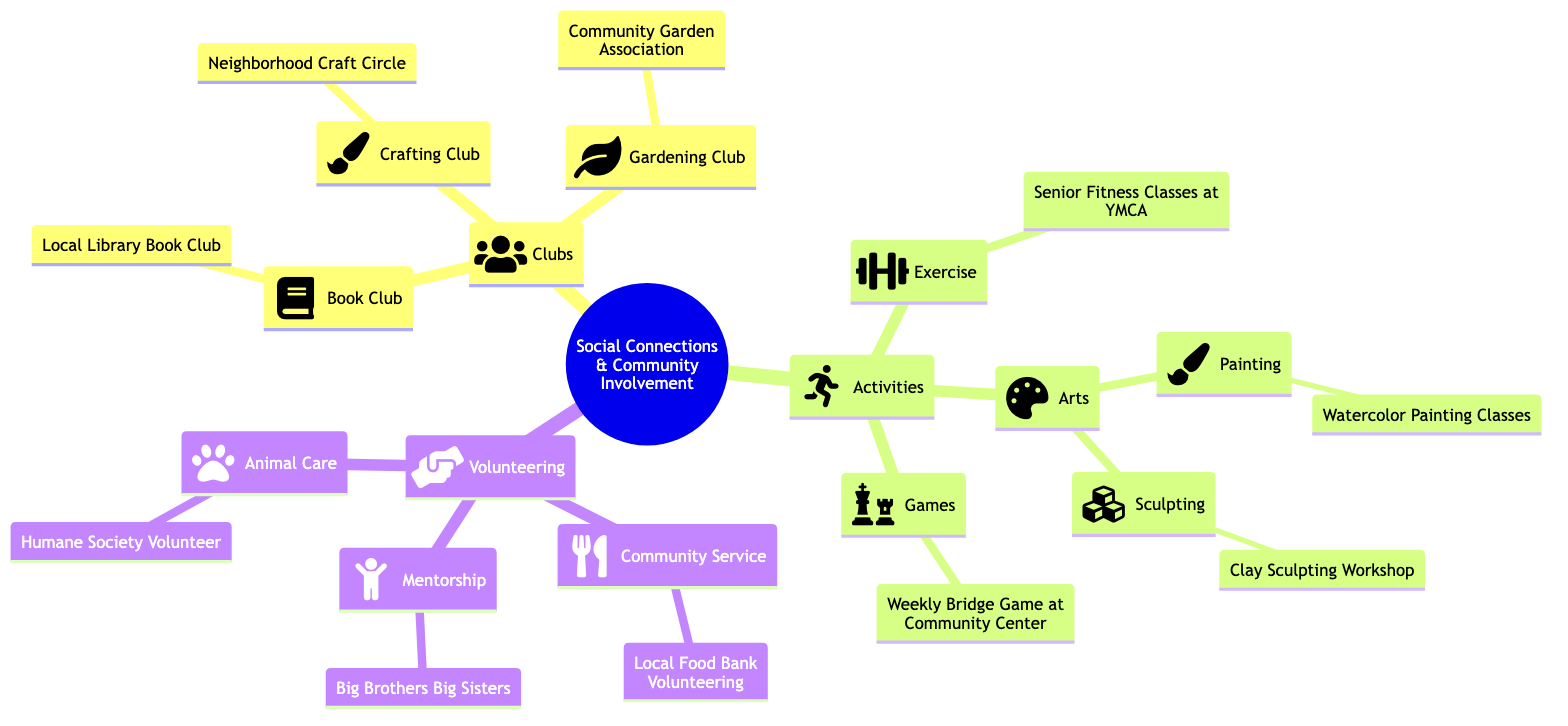What are the three types of social connections listed in the diagram? The diagram categorizes social connections into three main types: Clubs, Activities, and Volunteering. This can be directly observed as the primary branches of the mind map.
Answer: Clubs, Activities, Volunteering How many clubs are mentioned in the diagram? By counting the nodes under the "Clubs" category, there are three clubs listed: Book Club, Gardening Club, and Crafting Club.
Answer: 3 What is the name of the painting activity? Under the "Arts" category, the painting activity is specifically labeled as Watercolor Painting Classes, which is found in the sub-category of Painting.
Answer: Watercolor Painting Classes Which community service option is available for volunteering? The diagram lists Local Food Bank Volunteering under the Community Service category, making it the specific option mentioned for that type of volunteering.
Answer: Local Food Bank Volunteering What activity would you find at the YMCA? The diagram specifies that Senior Fitness Classes are conducted at the YMCA under the "Exercise" category, showing a direct link to that particular activity and location.
Answer: Senior Fitness Classes at YMCA Which club is associated with crafting activities? The relevant club for crafting activities is identified in the diagram as Neighborhood Craft Circle, which is nested under the Crafting Club section.
Answer: Neighborhood Craft Circle How many activities are listed in total under the "Activities" section? Evaluating the "Activities" section, there are three main categories: Exercise, Arts (which includes Painting and Sculpting), and Games. This totals to five activities when counting each individually.
Answer: 5 Which organization offers mentorship opportunities? The "Volunteering" section indicates that Big Brothers Big Sisters is the organization that provides mentorship opportunities, clearly stated under the Mentorship category.
Answer: Big Brothers Big Sisters What type of volunteering is related to animal care? The diagram clearly mentions Humane Society Volunteer as the volunteering option associated with animal care. This is directly found under the Animal Care category.
Answer: Humane Society Volunteer 